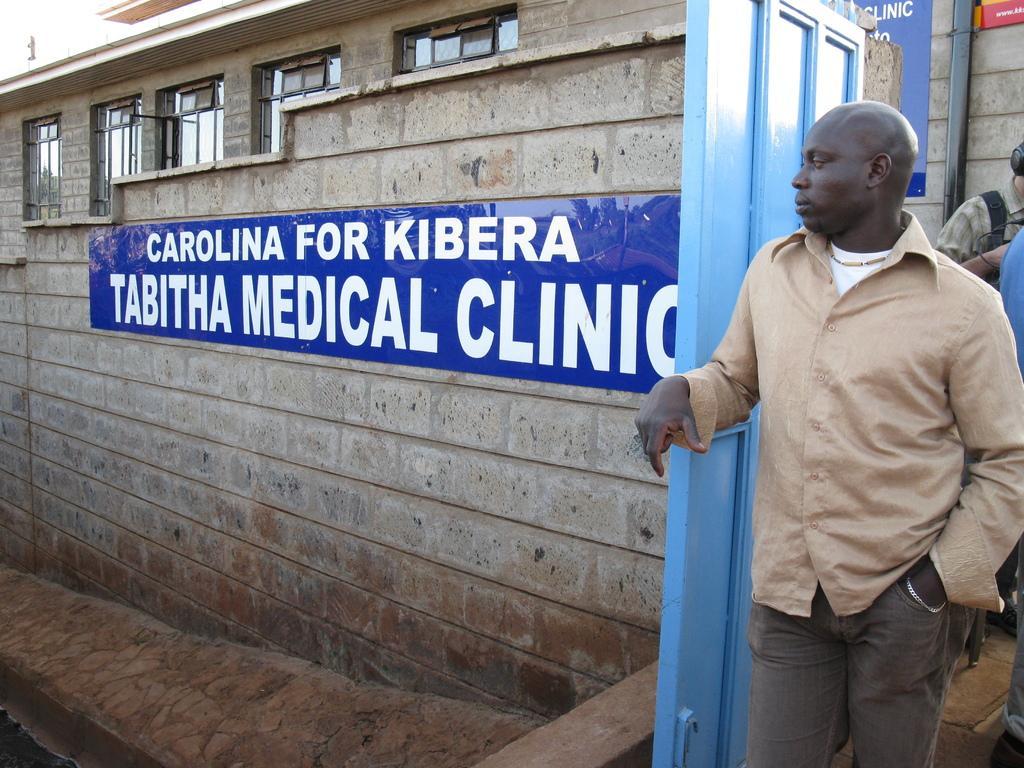Describe this image in one or two sentences. In this image we can see a building with windows, a wall with board and text on the board in front of the building and there are three persons on the right side and a person is standing beside the door. 